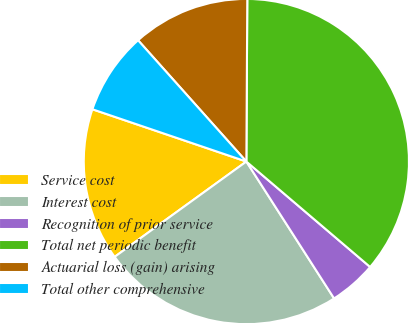<chart> <loc_0><loc_0><loc_500><loc_500><pie_chart><fcel>Service cost<fcel>Interest cost<fcel>Recognition of prior service<fcel>Total net periodic benefit<fcel>Actuarial loss (gain) arising<fcel>Total other comprehensive<nl><fcel>15.18%<fcel>24.1%<fcel>4.7%<fcel>36.14%<fcel>11.69%<fcel>8.19%<nl></chart> 